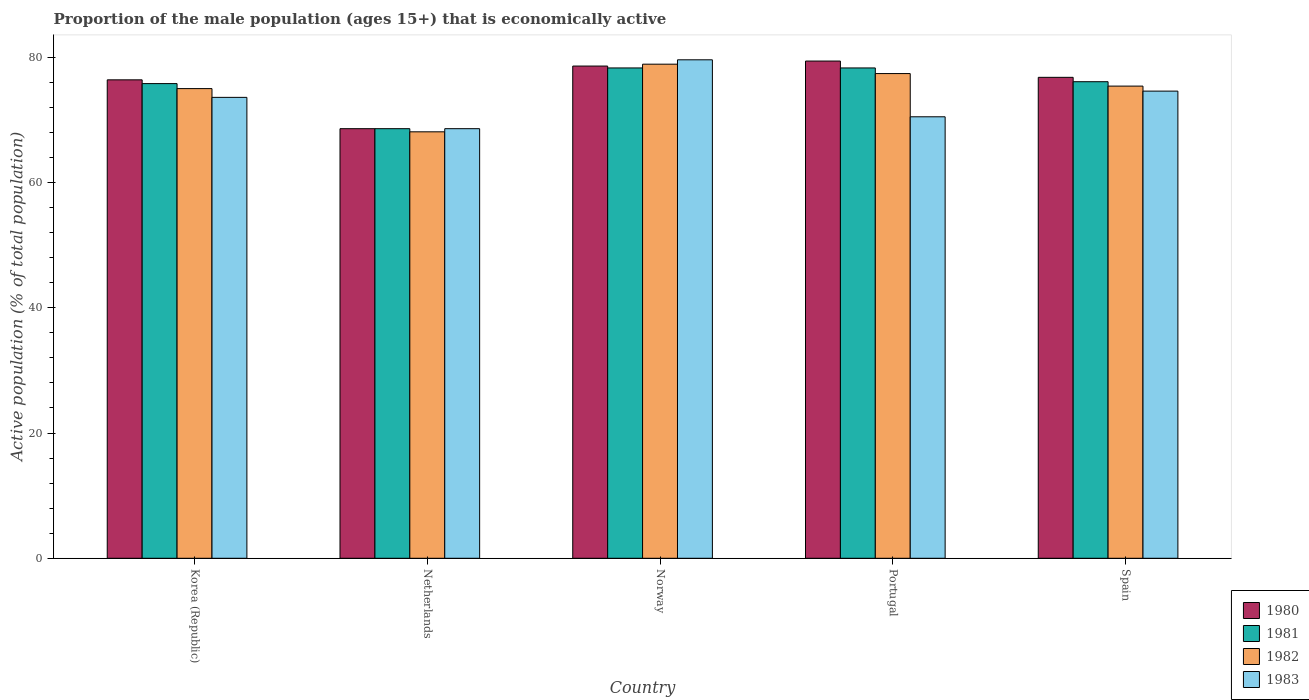How many groups of bars are there?
Make the answer very short. 5. Are the number of bars per tick equal to the number of legend labels?
Offer a terse response. Yes. How many bars are there on the 1st tick from the left?
Your answer should be compact. 4. How many bars are there on the 1st tick from the right?
Your answer should be compact. 4. In how many cases, is the number of bars for a given country not equal to the number of legend labels?
Provide a succinct answer. 0. Across all countries, what is the maximum proportion of the male population that is economically active in 1980?
Ensure brevity in your answer.  79.4. Across all countries, what is the minimum proportion of the male population that is economically active in 1981?
Provide a short and direct response. 68.6. In which country was the proportion of the male population that is economically active in 1982 maximum?
Provide a succinct answer. Norway. In which country was the proportion of the male population that is economically active in 1982 minimum?
Provide a short and direct response. Netherlands. What is the total proportion of the male population that is economically active in 1982 in the graph?
Your response must be concise. 374.8. What is the difference between the proportion of the male population that is economically active in 1981 in Korea (Republic) and that in Norway?
Offer a terse response. -2.5. What is the difference between the proportion of the male population that is economically active in 1981 in Korea (Republic) and the proportion of the male population that is economically active in 1982 in Spain?
Offer a very short reply. 0.4. What is the average proportion of the male population that is economically active in 1982 per country?
Keep it short and to the point. 74.96. What is the difference between the proportion of the male population that is economically active of/in 1980 and proportion of the male population that is economically active of/in 1982 in Netherlands?
Keep it short and to the point. 0.5. In how many countries, is the proportion of the male population that is economically active in 1981 greater than 64 %?
Your response must be concise. 5. What is the ratio of the proportion of the male population that is economically active in 1980 in Korea (Republic) to that in Norway?
Your answer should be very brief. 0.97. Is the proportion of the male population that is economically active in 1982 in Netherlands less than that in Spain?
Your response must be concise. Yes. What is the difference between the highest and the second highest proportion of the male population that is economically active in 1980?
Provide a succinct answer. -1.8. What is the difference between the highest and the lowest proportion of the male population that is economically active in 1983?
Offer a very short reply. 11. In how many countries, is the proportion of the male population that is economically active in 1980 greater than the average proportion of the male population that is economically active in 1980 taken over all countries?
Provide a succinct answer. 4. Is it the case that in every country, the sum of the proportion of the male population that is economically active in 1982 and proportion of the male population that is economically active in 1981 is greater than the proportion of the male population that is economically active in 1980?
Give a very brief answer. Yes. Are all the bars in the graph horizontal?
Offer a very short reply. No. How many countries are there in the graph?
Keep it short and to the point. 5. What is the difference between two consecutive major ticks on the Y-axis?
Your response must be concise. 20. Are the values on the major ticks of Y-axis written in scientific E-notation?
Provide a short and direct response. No. Does the graph contain any zero values?
Give a very brief answer. No. Does the graph contain grids?
Give a very brief answer. No. What is the title of the graph?
Your answer should be very brief. Proportion of the male population (ages 15+) that is economically active. What is the label or title of the Y-axis?
Provide a short and direct response. Active population (% of total population). What is the Active population (% of total population) in 1980 in Korea (Republic)?
Provide a short and direct response. 76.4. What is the Active population (% of total population) of 1981 in Korea (Republic)?
Your answer should be compact. 75.8. What is the Active population (% of total population) of 1982 in Korea (Republic)?
Ensure brevity in your answer.  75. What is the Active population (% of total population) of 1983 in Korea (Republic)?
Your response must be concise. 73.6. What is the Active population (% of total population) of 1980 in Netherlands?
Your answer should be very brief. 68.6. What is the Active population (% of total population) of 1981 in Netherlands?
Give a very brief answer. 68.6. What is the Active population (% of total population) of 1982 in Netherlands?
Give a very brief answer. 68.1. What is the Active population (% of total population) in 1983 in Netherlands?
Give a very brief answer. 68.6. What is the Active population (% of total population) of 1980 in Norway?
Give a very brief answer. 78.6. What is the Active population (% of total population) of 1981 in Norway?
Offer a terse response. 78.3. What is the Active population (% of total population) of 1982 in Norway?
Offer a terse response. 78.9. What is the Active population (% of total population) in 1983 in Norway?
Your answer should be very brief. 79.6. What is the Active population (% of total population) in 1980 in Portugal?
Your answer should be very brief. 79.4. What is the Active population (% of total population) in 1981 in Portugal?
Keep it short and to the point. 78.3. What is the Active population (% of total population) of 1982 in Portugal?
Give a very brief answer. 77.4. What is the Active population (% of total population) of 1983 in Portugal?
Provide a short and direct response. 70.5. What is the Active population (% of total population) in 1980 in Spain?
Ensure brevity in your answer.  76.8. What is the Active population (% of total population) of 1981 in Spain?
Your answer should be very brief. 76.1. What is the Active population (% of total population) in 1982 in Spain?
Offer a terse response. 75.4. What is the Active population (% of total population) in 1983 in Spain?
Provide a succinct answer. 74.6. Across all countries, what is the maximum Active population (% of total population) in 1980?
Provide a short and direct response. 79.4. Across all countries, what is the maximum Active population (% of total population) of 1981?
Keep it short and to the point. 78.3. Across all countries, what is the maximum Active population (% of total population) in 1982?
Provide a short and direct response. 78.9. Across all countries, what is the maximum Active population (% of total population) of 1983?
Give a very brief answer. 79.6. Across all countries, what is the minimum Active population (% of total population) of 1980?
Your answer should be compact. 68.6. Across all countries, what is the minimum Active population (% of total population) of 1981?
Make the answer very short. 68.6. Across all countries, what is the minimum Active population (% of total population) of 1982?
Your answer should be compact. 68.1. Across all countries, what is the minimum Active population (% of total population) of 1983?
Provide a short and direct response. 68.6. What is the total Active population (% of total population) in 1980 in the graph?
Your answer should be very brief. 379.8. What is the total Active population (% of total population) of 1981 in the graph?
Give a very brief answer. 377.1. What is the total Active population (% of total population) of 1982 in the graph?
Your answer should be compact. 374.8. What is the total Active population (% of total population) in 1983 in the graph?
Provide a short and direct response. 366.9. What is the difference between the Active population (% of total population) in 1980 in Korea (Republic) and that in Netherlands?
Your response must be concise. 7.8. What is the difference between the Active population (% of total population) of 1982 in Korea (Republic) and that in Netherlands?
Make the answer very short. 6.9. What is the difference between the Active population (% of total population) of 1980 in Korea (Republic) and that in Portugal?
Offer a terse response. -3. What is the difference between the Active population (% of total population) in 1982 in Korea (Republic) and that in Portugal?
Ensure brevity in your answer.  -2.4. What is the difference between the Active population (% of total population) in 1980 in Korea (Republic) and that in Spain?
Offer a very short reply. -0.4. What is the difference between the Active population (% of total population) of 1981 in Korea (Republic) and that in Spain?
Ensure brevity in your answer.  -0.3. What is the difference between the Active population (% of total population) of 1983 in Korea (Republic) and that in Spain?
Make the answer very short. -1. What is the difference between the Active population (% of total population) in 1981 in Netherlands and that in Portugal?
Keep it short and to the point. -9.7. What is the difference between the Active population (% of total population) of 1980 in Netherlands and that in Spain?
Ensure brevity in your answer.  -8.2. What is the difference between the Active population (% of total population) in 1983 in Netherlands and that in Spain?
Provide a succinct answer. -6. What is the difference between the Active population (% of total population) in 1980 in Norway and that in Portugal?
Provide a succinct answer. -0.8. What is the difference between the Active population (% of total population) in 1981 in Norway and that in Spain?
Your answer should be compact. 2.2. What is the difference between the Active population (% of total population) in 1982 in Norway and that in Spain?
Your response must be concise. 3.5. What is the difference between the Active population (% of total population) of 1980 in Portugal and that in Spain?
Give a very brief answer. 2.6. What is the difference between the Active population (% of total population) of 1981 in Portugal and that in Spain?
Your answer should be very brief. 2.2. What is the difference between the Active population (% of total population) of 1980 in Korea (Republic) and the Active population (% of total population) of 1982 in Netherlands?
Provide a succinct answer. 8.3. What is the difference between the Active population (% of total population) of 1980 in Korea (Republic) and the Active population (% of total population) of 1983 in Netherlands?
Your answer should be compact. 7.8. What is the difference between the Active population (% of total population) of 1982 in Korea (Republic) and the Active population (% of total population) of 1983 in Netherlands?
Your answer should be very brief. 6.4. What is the difference between the Active population (% of total population) of 1980 in Korea (Republic) and the Active population (% of total population) of 1982 in Norway?
Provide a succinct answer. -2.5. What is the difference between the Active population (% of total population) in 1980 in Korea (Republic) and the Active population (% of total population) in 1982 in Portugal?
Provide a short and direct response. -1. What is the difference between the Active population (% of total population) of 1981 in Korea (Republic) and the Active population (% of total population) of 1982 in Portugal?
Make the answer very short. -1.6. What is the difference between the Active population (% of total population) of 1982 in Korea (Republic) and the Active population (% of total population) of 1983 in Portugal?
Offer a terse response. 4.5. What is the difference between the Active population (% of total population) of 1982 in Korea (Republic) and the Active population (% of total population) of 1983 in Spain?
Your answer should be very brief. 0.4. What is the difference between the Active population (% of total population) in 1980 in Netherlands and the Active population (% of total population) in 1982 in Norway?
Make the answer very short. -10.3. What is the difference between the Active population (% of total population) in 1980 in Netherlands and the Active population (% of total population) in 1983 in Norway?
Provide a short and direct response. -11. What is the difference between the Active population (% of total population) of 1981 in Netherlands and the Active population (% of total population) of 1982 in Norway?
Provide a succinct answer. -10.3. What is the difference between the Active population (% of total population) of 1980 in Netherlands and the Active population (% of total population) of 1982 in Portugal?
Your answer should be compact. -8.8. What is the difference between the Active population (% of total population) in 1980 in Netherlands and the Active population (% of total population) in 1983 in Portugal?
Keep it short and to the point. -1.9. What is the difference between the Active population (% of total population) in 1981 in Netherlands and the Active population (% of total population) in 1982 in Portugal?
Provide a short and direct response. -8.8. What is the difference between the Active population (% of total population) of 1981 in Netherlands and the Active population (% of total population) of 1983 in Portugal?
Provide a short and direct response. -1.9. What is the difference between the Active population (% of total population) in 1982 in Netherlands and the Active population (% of total population) in 1983 in Portugal?
Your response must be concise. -2.4. What is the difference between the Active population (% of total population) of 1980 in Netherlands and the Active population (% of total population) of 1983 in Spain?
Offer a very short reply. -6. What is the difference between the Active population (% of total population) of 1981 in Netherlands and the Active population (% of total population) of 1983 in Spain?
Provide a short and direct response. -6. What is the difference between the Active population (% of total population) of 1982 in Netherlands and the Active population (% of total population) of 1983 in Spain?
Provide a short and direct response. -6.5. What is the difference between the Active population (% of total population) in 1980 in Norway and the Active population (% of total population) in 1982 in Portugal?
Keep it short and to the point. 1.2. What is the difference between the Active population (% of total population) of 1981 in Norway and the Active population (% of total population) of 1982 in Portugal?
Give a very brief answer. 0.9. What is the difference between the Active population (% of total population) of 1982 in Norway and the Active population (% of total population) of 1983 in Portugal?
Your answer should be very brief. 8.4. What is the difference between the Active population (% of total population) of 1980 in Norway and the Active population (% of total population) of 1981 in Spain?
Your answer should be very brief. 2.5. What is the difference between the Active population (% of total population) in 1980 in Norway and the Active population (% of total population) in 1982 in Spain?
Offer a terse response. 3.2. What is the difference between the Active population (% of total population) in 1981 in Norway and the Active population (% of total population) in 1983 in Spain?
Offer a very short reply. 3.7. What is the difference between the Active population (% of total population) of 1982 in Norway and the Active population (% of total population) of 1983 in Spain?
Provide a succinct answer. 4.3. What is the difference between the Active population (% of total population) in 1980 in Portugal and the Active population (% of total population) in 1982 in Spain?
Give a very brief answer. 4. What is the difference between the Active population (% of total population) of 1980 in Portugal and the Active population (% of total population) of 1983 in Spain?
Your answer should be very brief. 4.8. What is the average Active population (% of total population) of 1980 per country?
Your answer should be very brief. 75.96. What is the average Active population (% of total population) of 1981 per country?
Offer a terse response. 75.42. What is the average Active population (% of total population) in 1982 per country?
Give a very brief answer. 74.96. What is the average Active population (% of total population) in 1983 per country?
Keep it short and to the point. 73.38. What is the difference between the Active population (% of total population) of 1980 and Active population (% of total population) of 1981 in Korea (Republic)?
Your response must be concise. 0.6. What is the difference between the Active population (% of total population) in 1980 and Active population (% of total population) in 1983 in Korea (Republic)?
Provide a succinct answer. 2.8. What is the difference between the Active population (% of total population) of 1981 and Active population (% of total population) of 1982 in Korea (Republic)?
Your answer should be compact. 0.8. What is the difference between the Active population (% of total population) of 1981 and Active population (% of total population) of 1983 in Korea (Republic)?
Provide a succinct answer. 2.2. What is the difference between the Active population (% of total population) in 1980 and Active population (% of total population) in 1982 in Netherlands?
Ensure brevity in your answer.  0.5. What is the difference between the Active population (% of total population) in 1980 and Active population (% of total population) in 1983 in Netherlands?
Offer a very short reply. 0. What is the difference between the Active population (% of total population) in 1981 and Active population (% of total population) in 1982 in Netherlands?
Ensure brevity in your answer.  0.5. What is the difference between the Active population (% of total population) in 1981 and Active population (% of total population) in 1983 in Netherlands?
Give a very brief answer. 0. What is the difference between the Active population (% of total population) of 1982 and Active population (% of total population) of 1983 in Netherlands?
Provide a short and direct response. -0.5. What is the difference between the Active population (% of total population) in 1980 and Active population (% of total population) in 1982 in Norway?
Make the answer very short. -0.3. What is the difference between the Active population (% of total population) in 1981 and Active population (% of total population) in 1982 in Norway?
Ensure brevity in your answer.  -0.6. What is the difference between the Active population (% of total population) of 1982 and Active population (% of total population) of 1983 in Norway?
Make the answer very short. -0.7. What is the difference between the Active population (% of total population) of 1980 and Active population (% of total population) of 1982 in Portugal?
Offer a terse response. 2. What is the difference between the Active population (% of total population) in 1980 and Active population (% of total population) in 1983 in Spain?
Keep it short and to the point. 2.2. What is the difference between the Active population (% of total population) of 1981 and Active population (% of total population) of 1983 in Spain?
Keep it short and to the point. 1.5. What is the difference between the Active population (% of total population) in 1982 and Active population (% of total population) in 1983 in Spain?
Keep it short and to the point. 0.8. What is the ratio of the Active population (% of total population) of 1980 in Korea (Republic) to that in Netherlands?
Your answer should be compact. 1.11. What is the ratio of the Active population (% of total population) in 1981 in Korea (Republic) to that in Netherlands?
Give a very brief answer. 1.1. What is the ratio of the Active population (% of total population) in 1982 in Korea (Republic) to that in Netherlands?
Give a very brief answer. 1.1. What is the ratio of the Active population (% of total population) in 1983 in Korea (Republic) to that in Netherlands?
Offer a terse response. 1.07. What is the ratio of the Active population (% of total population) of 1980 in Korea (Republic) to that in Norway?
Provide a succinct answer. 0.97. What is the ratio of the Active population (% of total population) in 1981 in Korea (Republic) to that in Norway?
Keep it short and to the point. 0.97. What is the ratio of the Active population (% of total population) in 1982 in Korea (Republic) to that in Norway?
Keep it short and to the point. 0.95. What is the ratio of the Active population (% of total population) of 1983 in Korea (Republic) to that in Norway?
Offer a very short reply. 0.92. What is the ratio of the Active population (% of total population) of 1980 in Korea (Republic) to that in Portugal?
Offer a terse response. 0.96. What is the ratio of the Active population (% of total population) of 1981 in Korea (Republic) to that in Portugal?
Offer a terse response. 0.97. What is the ratio of the Active population (% of total population) of 1983 in Korea (Republic) to that in Portugal?
Your answer should be very brief. 1.04. What is the ratio of the Active population (% of total population) in 1980 in Korea (Republic) to that in Spain?
Offer a very short reply. 0.99. What is the ratio of the Active population (% of total population) of 1981 in Korea (Republic) to that in Spain?
Your response must be concise. 1. What is the ratio of the Active population (% of total population) of 1983 in Korea (Republic) to that in Spain?
Provide a succinct answer. 0.99. What is the ratio of the Active population (% of total population) of 1980 in Netherlands to that in Norway?
Your response must be concise. 0.87. What is the ratio of the Active population (% of total population) in 1981 in Netherlands to that in Norway?
Your answer should be compact. 0.88. What is the ratio of the Active population (% of total population) in 1982 in Netherlands to that in Norway?
Offer a very short reply. 0.86. What is the ratio of the Active population (% of total population) in 1983 in Netherlands to that in Norway?
Your answer should be compact. 0.86. What is the ratio of the Active population (% of total population) in 1980 in Netherlands to that in Portugal?
Make the answer very short. 0.86. What is the ratio of the Active population (% of total population) in 1981 in Netherlands to that in Portugal?
Keep it short and to the point. 0.88. What is the ratio of the Active population (% of total population) of 1982 in Netherlands to that in Portugal?
Your answer should be compact. 0.88. What is the ratio of the Active population (% of total population) of 1980 in Netherlands to that in Spain?
Keep it short and to the point. 0.89. What is the ratio of the Active population (% of total population) in 1981 in Netherlands to that in Spain?
Your answer should be compact. 0.9. What is the ratio of the Active population (% of total population) in 1982 in Netherlands to that in Spain?
Your answer should be very brief. 0.9. What is the ratio of the Active population (% of total population) in 1983 in Netherlands to that in Spain?
Your answer should be very brief. 0.92. What is the ratio of the Active population (% of total population) in 1981 in Norway to that in Portugal?
Your answer should be compact. 1. What is the ratio of the Active population (% of total population) in 1982 in Norway to that in Portugal?
Provide a short and direct response. 1.02. What is the ratio of the Active population (% of total population) in 1983 in Norway to that in Portugal?
Provide a short and direct response. 1.13. What is the ratio of the Active population (% of total population) of 1980 in Norway to that in Spain?
Offer a very short reply. 1.02. What is the ratio of the Active population (% of total population) of 1981 in Norway to that in Spain?
Your answer should be compact. 1.03. What is the ratio of the Active population (% of total population) in 1982 in Norway to that in Spain?
Your answer should be compact. 1.05. What is the ratio of the Active population (% of total population) of 1983 in Norway to that in Spain?
Keep it short and to the point. 1.07. What is the ratio of the Active population (% of total population) of 1980 in Portugal to that in Spain?
Give a very brief answer. 1.03. What is the ratio of the Active population (% of total population) of 1981 in Portugal to that in Spain?
Your response must be concise. 1.03. What is the ratio of the Active population (% of total population) in 1982 in Portugal to that in Spain?
Offer a very short reply. 1.03. What is the ratio of the Active population (% of total population) of 1983 in Portugal to that in Spain?
Your response must be concise. 0.94. What is the difference between the highest and the second highest Active population (% of total population) of 1983?
Keep it short and to the point. 5. What is the difference between the highest and the lowest Active population (% of total population) of 1982?
Your response must be concise. 10.8. 